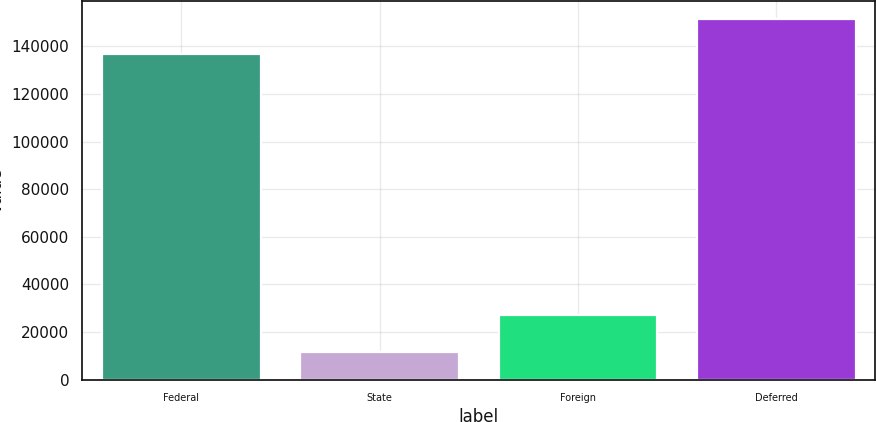<chart> <loc_0><loc_0><loc_500><loc_500><bar_chart><fcel>Federal<fcel>State<fcel>Foreign<fcel>Deferred<nl><fcel>136651<fcel>11771<fcel>27239<fcel>151640<nl></chart> 